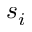Convert formula to latex. <formula><loc_0><loc_0><loc_500><loc_500>s _ { i }</formula> 